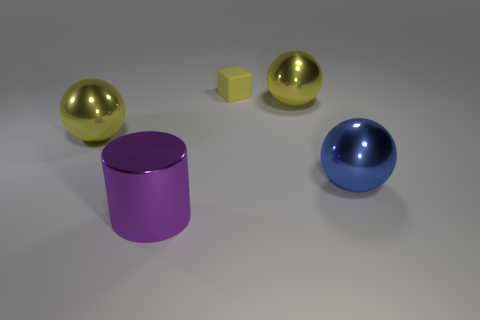Add 5 big blue shiny objects. How many objects exist? 10 Subtract all balls. How many objects are left? 2 Subtract all yellow cubes. Subtract all yellow balls. How many objects are left? 2 Add 5 large yellow metal things. How many large yellow metal things are left? 7 Add 4 spheres. How many spheres exist? 7 Subtract 1 yellow cubes. How many objects are left? 4 